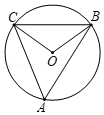What geometric principles can we learn from this circle diagram? This circle diagram illustrates several key geometric principles. First, it showcases the Inscribed Angle Theorem, which states that an inscribed angle is half the measure of its corresponding central angle. It also demonstrates the properties of isosceles triangles, where two sides are of equal length, showing that the base angles are equal. Additionally, the concept that the sum of angles in a triangle equals 180 degrees is used to find the angles at B and C. Lastly, it touches on the concept of congruent arcs and how they relate to the angles within the circle. 